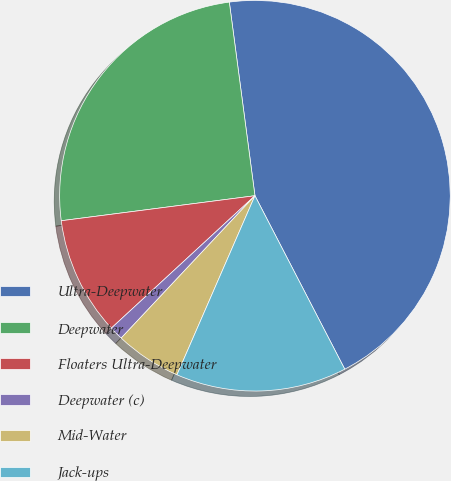Convert chart to OTSL. <chart><loc_0><loc_0><loc_500><loc_500><pie_chart><fcel>Ultra-Deepwater<fcel>Deepwater<fcel>Floaters Ultra-Deepwater<fcel>Deepwater (c)<fcel>Mid-Water<fcel>Jack-ups<nl><fcel>44.49%<fcel>24.95%<fcel>9.81%<fcel>1.14%<fcel>5.47%<fcel>14.14%<nl></chart> 